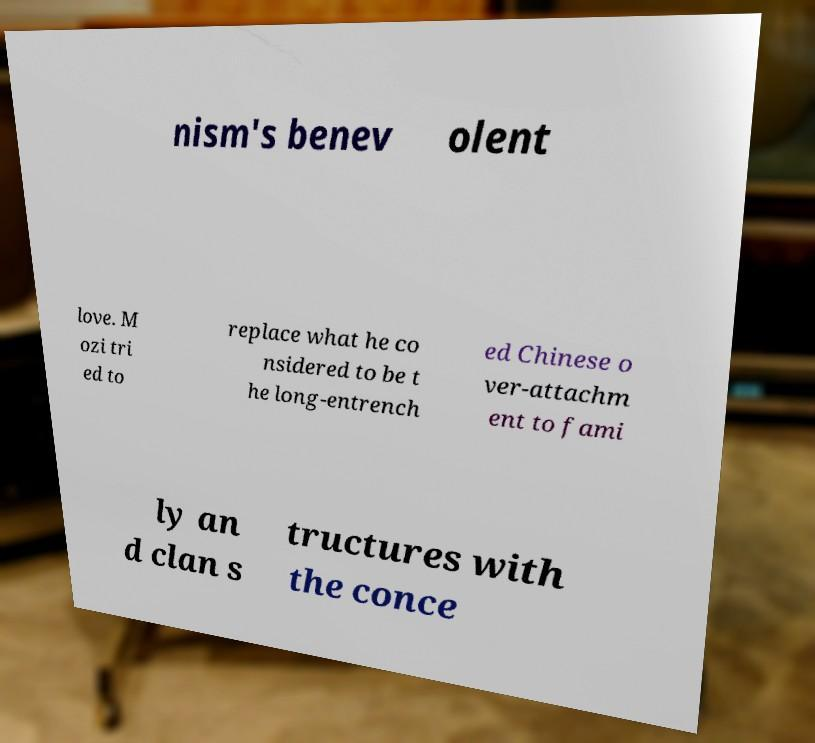Could you assist in decoding the text presented in this image and type it out clearly? nism's benev olent love. M ozi tri ed to replace what he co nsidered to be t he long-entrench ed Chinese o ver-attachm ent to fami ly an d clan s tructures with the conce 